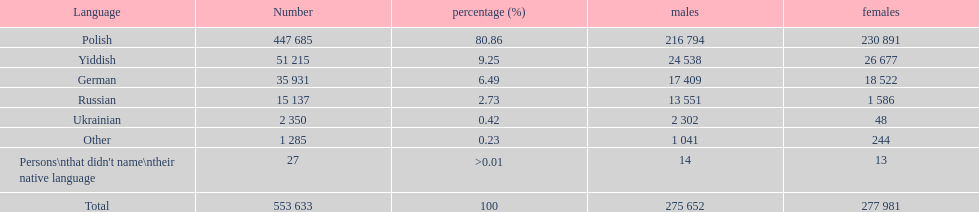How many languages have a name that is derived from a country? 4. 